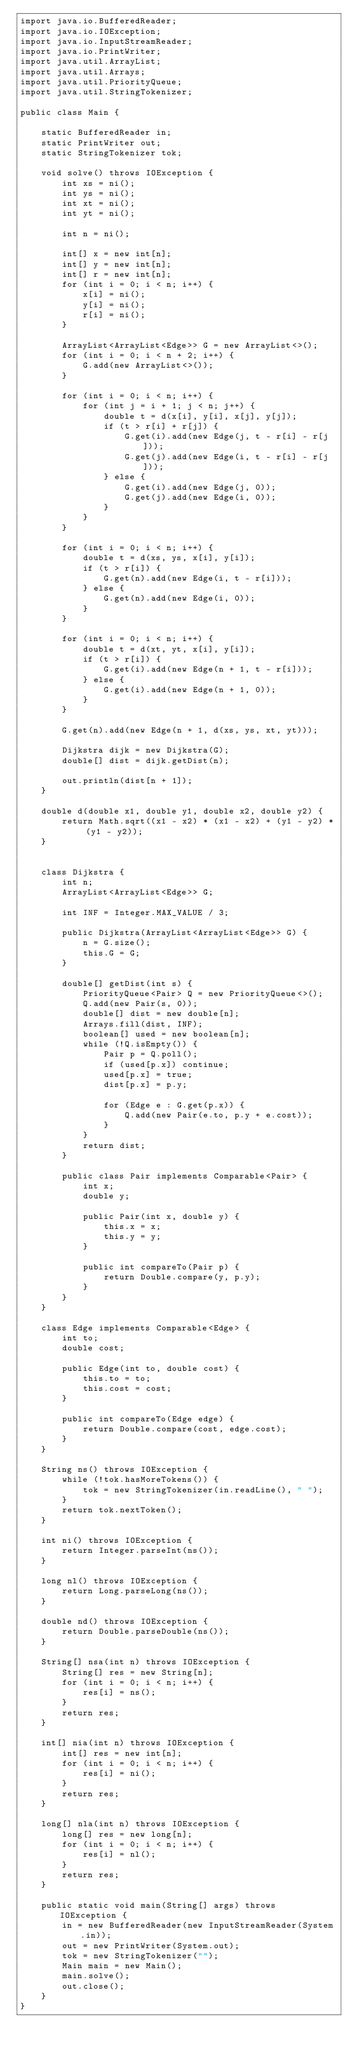<code> <loc_0><loc_0><loc_500><loc_500><_Java_>import java.io.BufferedReader;
import java.io.IOException;
import java.io.InputStreamReader;
import java.io.PrintWriter;
import java.util.ArrayList;
import java.util.Arrays;
import java.util.PriorityQueue;
import java.util.StringTokenizer;

public class Main {

    static BufferedReader in;
    static PrintWriter out;
    static StringTokenizer tok;

    void solve() throws IOException {
        int xs = ni();
        int ys = ni();
        int xt = ni();
        int yt = ni();

        int n = ni();

        int[] x = new int[n];
        int[] y = new int[n];
        int[] r = new int[n];
        for (int i = 0; i < n; i++) {
            x[i] = ni();
            y[i] = ni();
            r[i] = ni();
        }

        ArrayList<ArrayList<Edge>> G = new ArrayList<>();
        for (int i = 0; i < n + 2; i++) {
            G.add(new ArrayList<>());
        }

        for (int i = 0; i < n; i++) {
            for (int j = i + 1; j < n; j++) {
                double t = d(x[i], y[i], x[j], y[j]);
                if (t > r[i] + r[j]) {
                    G.get(i).add(new Edge(j, t - r[i] - r[j]));
                    G.get(j).add(new Edge(i, t - r[i] - r[j]));
                } else {
                    G.get(i).add(new Edge(j, 0));
                    G.get(j).add(new Edge(i, 0));
                }
            }
        }

        for (int i = 0; i < n; i++) {
            double t = d(xs, ys, x[i], y[i]);
            if (t > r[i]) {
                G.get(n).add(new Edge(i, t - r[i]));
            } else {
                G.get(n).add(new Edge(i, 0));
            }
        }

        for (int i = 0; i < n; i++) {
            double t = d(xt, yt, x[i], y[i]);
            if (t > r[i]) {
                G.get(i).add(new Edge(n + 1, t - r[i]));
            } else {
                G.get(i).add(new Edge(n + 1, 0));
            }
        }

        G.get(n).add(new Edge(n + 1, d(xs, ys, xt, yt)));

        Dijkstra dijk = new Dijkstra(G);
        double[] dist = dijk.getDist(n);

        out.println(dist[n + 1]);
    }

    double d(double x1, double y1, double x2, double y2) {
        return Math.sqrt((x1 - x2) * (x1 - x2) + (y1 - y2) * (y1 - y2));
    }


    class Dijkstra {
        int n;
        ArrayList<ArrayList<Edge>> G;

        int INF = Integer.MAX_VALUE / 3;

        public Dijkstra(ArrayList<ArrayList<Edge>> G) {
            n = G.size();
            this.G = G;
        }

        double[] getDist(int s) {
            PriorityQueue<Pair> Q = new PriorityQueue<>();
            Q.add(new Pair(s, 0));
            double[] dist = new double[n];
            Arrays.fill(dist, INF);
            boolean[] used = new boolean[n];
            while (!Q.isEmpty()) {
                Pair p = Q.poll();
                if (used[p.x]) continue;
                used[p.x] = true;
                dist[p.x] = p.y;

                for (Edge e : G.get(p.x)) {
                    Q.add(new Pair(e.to, p.y + e.cost));
                }
            }
            return dist;
        }

        public class Pair implements Comparable<Pair> {
            int x;
            double y;

            public Pair(int x, double y) {
                this.x = x;
                this.y = y;
            }

            public int compareTo(Pair p) {
                return Double.compare(y, p.y);
            }
        }
    }

    class Edge implements Comparable<Edge> {
        int to;
        double cost;

        public Edge(int to, double cost) {
            this.to = to;
            this.cost = cost;
        }

        public int compareTo(Edge edge) {
            return Double.compare(cost, edge.cost);
        }
    }

    String ns() throws IOException {
        while (!tok.hasMoreTokens()) {
            tok = new StringTokenizer(in.readLine(), " ");
        }
        return tok.nextToken();
    }

    int ni() throws IOException {
        return Integer.parseInt(ns());
    }

    long nl() throws IOException {
        return Long.parseLong(ns());
    }

    double nd() throws IOException {
        return Double.parseDouble(ns());
    }

    String[] nsa(int n) throws IOException {
        String[] res = new String[n];
        for (int i = 0; i < n; i++) {
            res[i] = ns();
        }
        return res;
    }

    int[] nia(int n) throws IOException {
        int[] res = new int[n];
        for (int i = 0; i < n; i++) {
            res[i] = ni();
        }
        return res;
    }

    long[] nla(int n) throws IOException {
        long[] res = new long[n];
        for (int i = 0; i < n; i++) {
            res[i] = nl();
        }
        return res;
    }

    public static void main(String[] args) throws IOException {
        in = new BufferedReader(new InputStreamReader(System.in));
        out = new PrintWriter(System.out);
        tok = new StringTokenizer("");
        Main main = new Main();
        main.solve();
        out.close();
    }
}</code> 